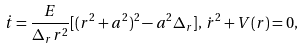<formula> <loc_0><loc_0><loc_500><loc_500>\dot { t } = \frac { E } { \Delta _ { r } r ^ { 2 } } [ ( r ^ { 2 } + a ^ { 2 } ) ^ { 2 } - a ^ { 2 } \Delta _ { r } ] , \, \dot { r } ^ { 2 } + V ( r ) = 0 ,</formula> 